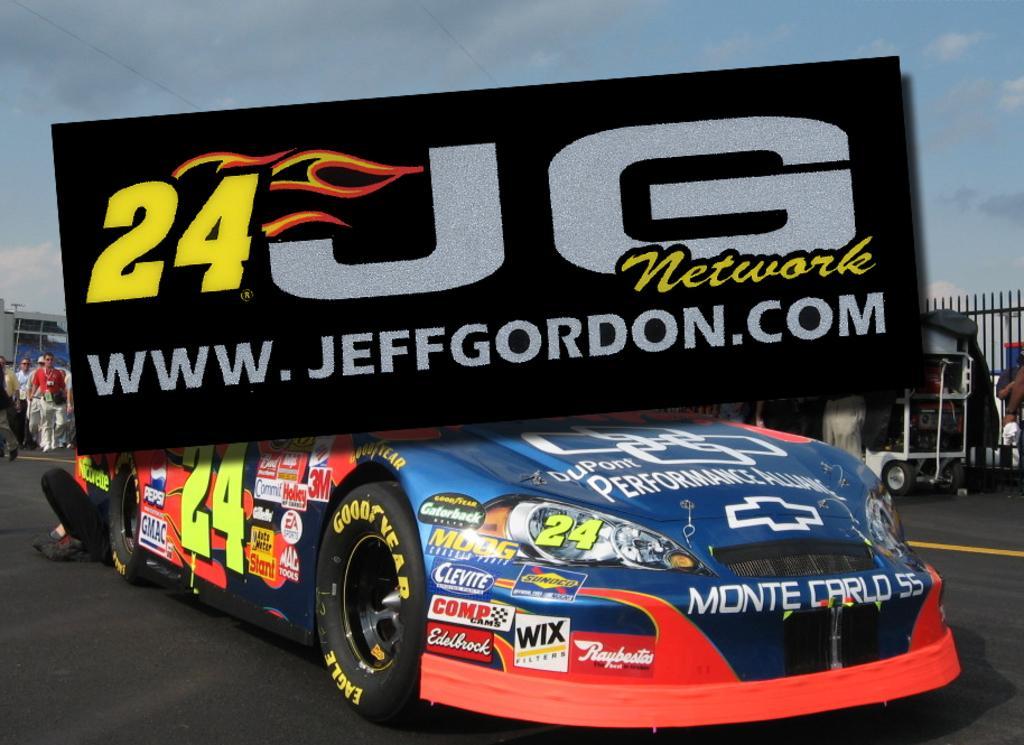How would you summarize this image in a sentence or two? This is an edited image. I can see a car on the road. On the right side of the image, there are few objects and an iron grille. On the right side of the image, I can see a group of people standing. In the background, there is the sky. At the center of the image, there is a board. 